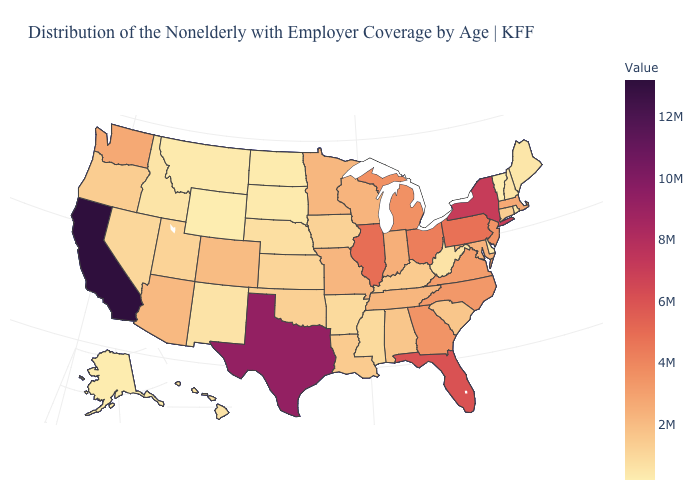Among the states that border Colorado , which have the lowest value?
Short answer required. Wyoming. Which states have the lowest value in the USA?
Be succinct. Wyoming. Among the states that border New Hampshire , which have the lowest value?
Be succinct. Vermont. Among the states that border Colorado , does Wyoming have the lowest value?
Be succinct. Yes. Does Nebraska have the lowest value in the MidWest?
Quick response, please. No. 